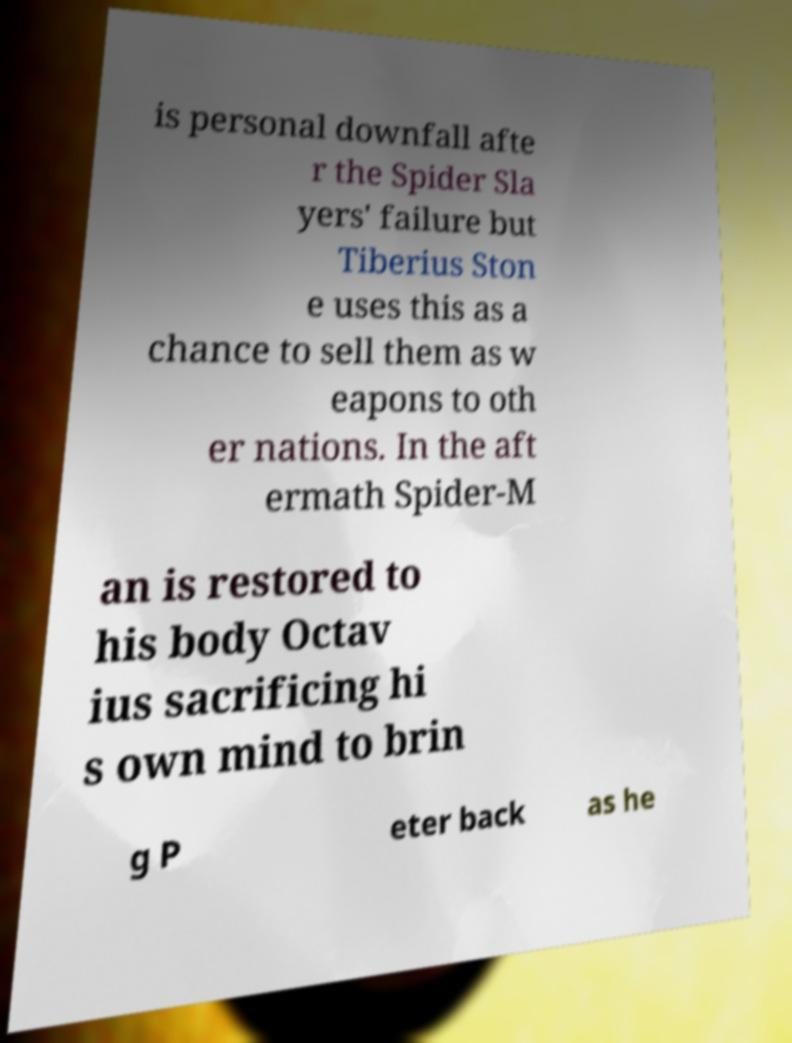Please identify and transcribe the text found in this image. is personal downfall afte r the Spider Sla yers' failure but Tiberius Ston e uses this as a chance to sell them as w eapons to oth er nations. In the aft ermath Spider-M an is restored to his body Octav ius sacrificing hi s own mind to brin g P eter back as he 